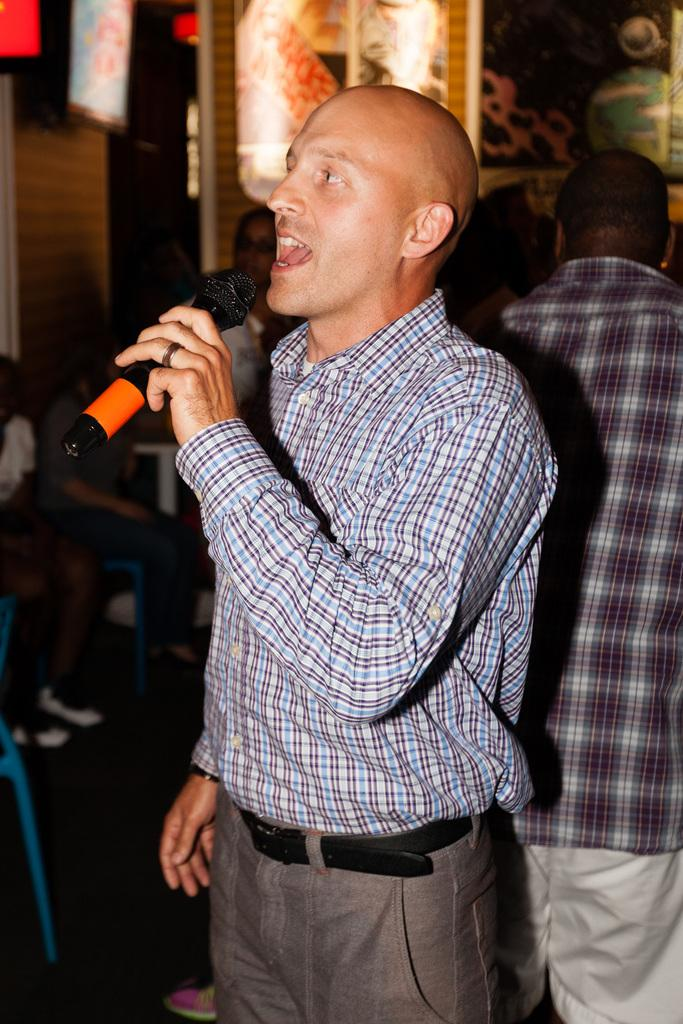What is the main subject of the image? There is a person in the image. What is the person wearing that is mentioned in the facts? The person is wearing a black belt. What is the person doing in the image? The person is standing and singing. What object is the person in front of? The person is in front of a microphone. Can you describe the background of the image? There is a group of people behind the person. What type of dirt can be seen on the person's shoes in the image? There is no dirt visible on the person's shoes in the image. Can you tell me how many tubs are present in the image? There are no tubs present in the image. 